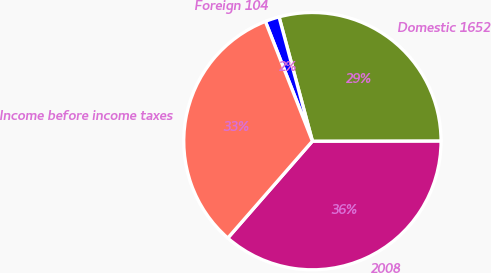Convert chart. <chart><loc_0><loc_0><loc_500><loc_500><pie_chart><fcel>2008<fcel>Domestic 1652<fcel>Foreign 104<fcel>Income before income taxes<nl><fcel>36.45%<fcel>29.15%<fcel>1.78%<fcel>32.62%<nl></chart> 